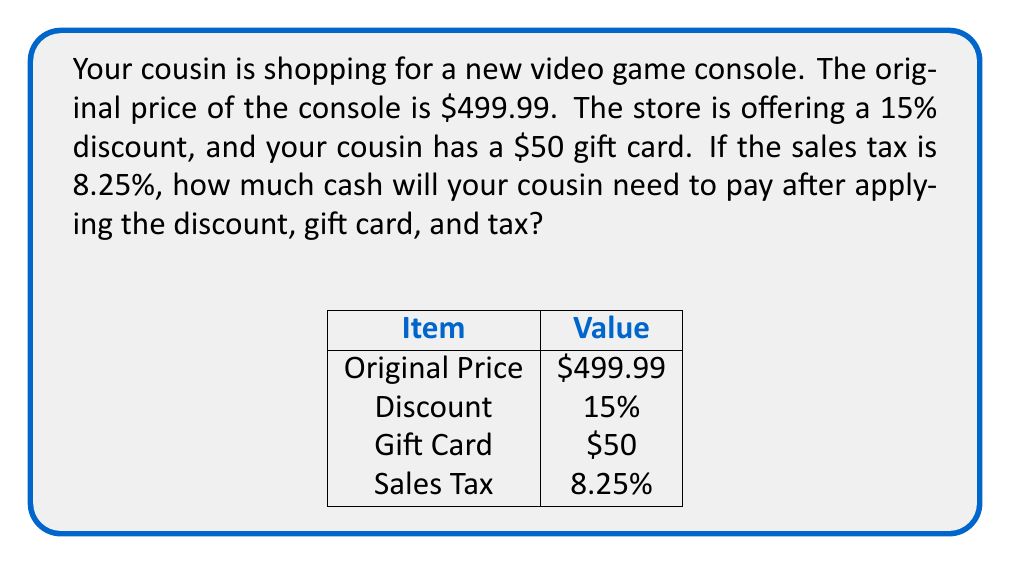Solve this math problem. Let's break this down step-by-step:

1) First, calculate the discount amount:
   $15\% \text{ of } \$499.99 = 0.15 \times \$499.99 = \$74.9985$

2) Subtract the discount from the original price:
   $\$499.99 - \$74.9985 = \$425.0015$

3) Apply the gift card:
   $\$425.0015 - \$50 = \$375.0015$

4) Calculate the tax on this amount:
   $8.25\% \text{ of } \$375.0015 = 0.0825 \times \$375.0015 = \$30.9376$

5) Add the tax to get the final price:
   $\$375.0015 + \$30.9376 = \$405.9391$

6) Round to the nearest cent:
   $\$405.94$

Therefore, your cousin will need to pay $\$405.94 in cash.
Answer: $\$405.94$ 